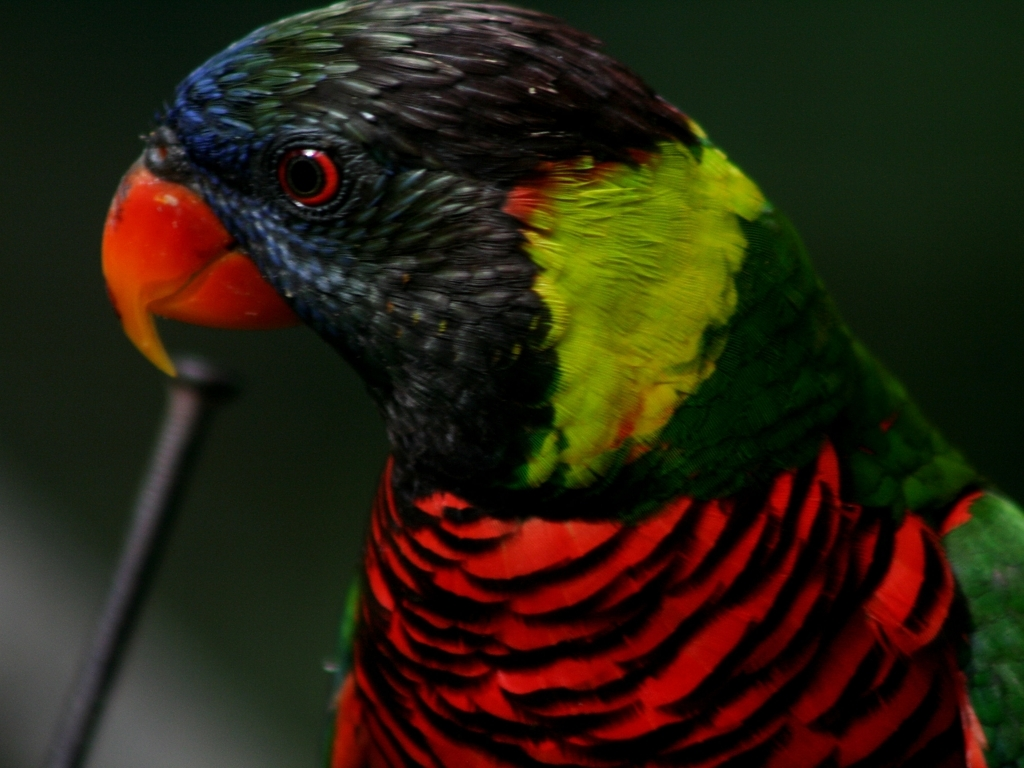Could you describe the characteristics of this parrot that differentiate it from other parrot species? Distinctive traits of the Rainbow Lorikeet include their vivid multi-colored plumage, with blue head and belly, green wings and back, and a red chest with black-blue stripes. Additionally, they have a unique brush-tipped tongue for feeding on nectar and soft fruits, setting them apart from other species of parrots. 